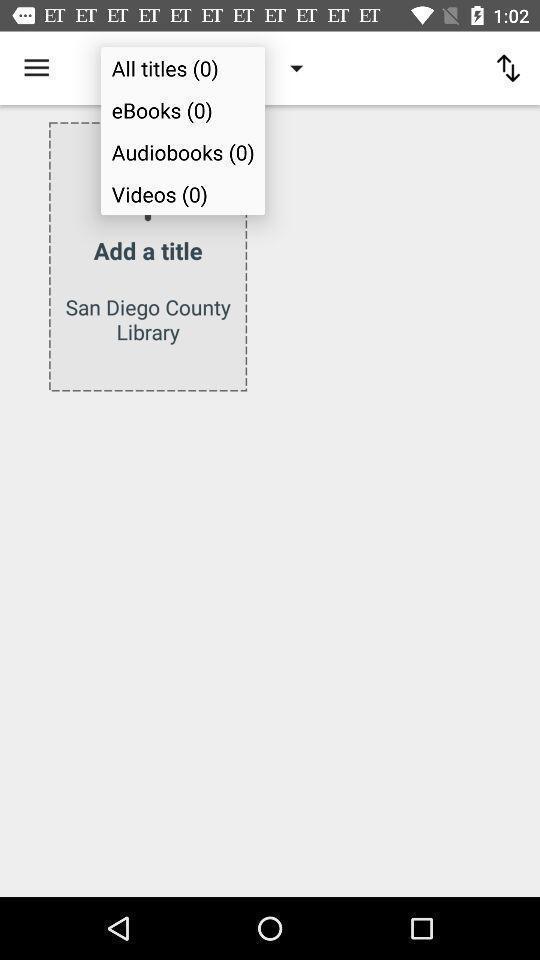Summarize the main components in this picture. Page to add title in the book reading app. 